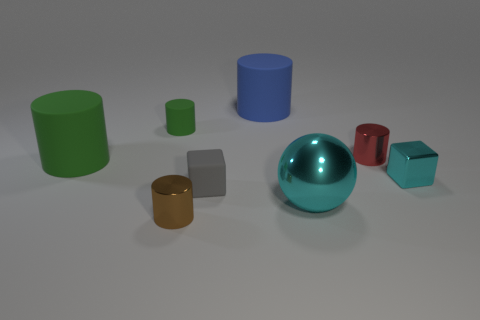Subtract all green rubber cylinders. How many cylinders are left? 3 Subtract all brown cylinders. How many cylinders are left? 4 Subtract all gray cylinders. Subtract all blue blocks. How many cylinders are left? 5 Add 2 green matte blocks. How many objects exist? 10 Subtract 0 purple cubes. How many objects are left? 8 Subtract all balls. How many objects are left? 7 Subtract all tiny purple shiny balls. Subtract all gray blocks. How many objects are left? 7 Add 4 small cylinders. How many small cylinders are left? 7 Add 6 small blue matte balls. How many small blue matte balls exist? 6 